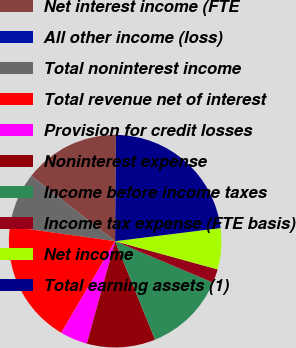Convert chart. <chart><loc_0><loc_0><loc_500><loc_500><pie_chart><fcel>Net interest income (FTE<fcel>All other income (loss)<fcel>Total noninterest income<fcel>Total revenue net of interest<fcel>Provision for credit losses<fcel>Noninterest expense<fcel>Income before income taxes<fcel>Income tax expense (FTE basis)<fcel>Net income<fcel>Total earning assets (1)<nl><fcel>14.58%<fcel>0.01%<fcel>8.33%<fcel>18.74%<fcel>4.17%<fcel>10.42%<fcel>12.5%<fcel>2.09%<fcel>6.25%<fcel>22.9%<nl></chart> 